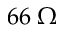<formula> <loc_0><loc_0><loc_500><loc_500>6 6 \, \Omega</formula> 